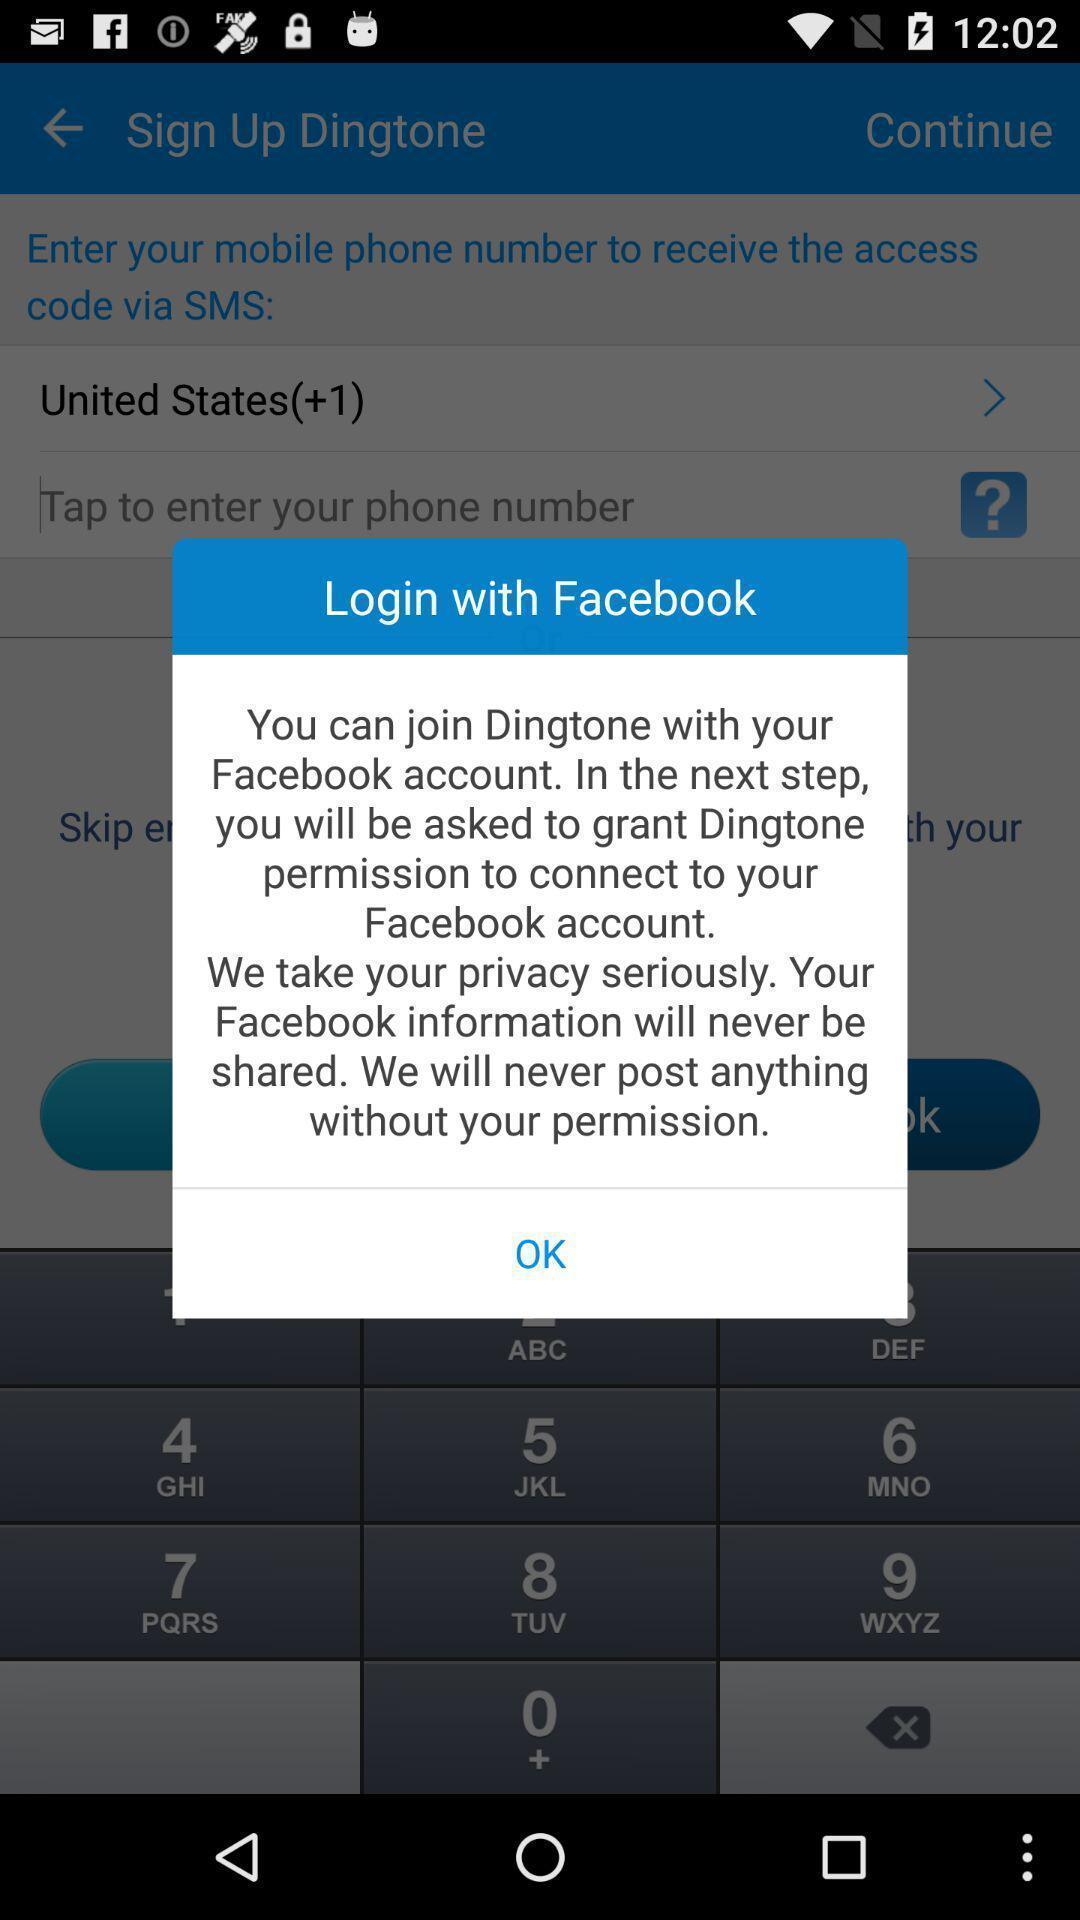Please provide a description for this image. Popup to login in the calling app. 